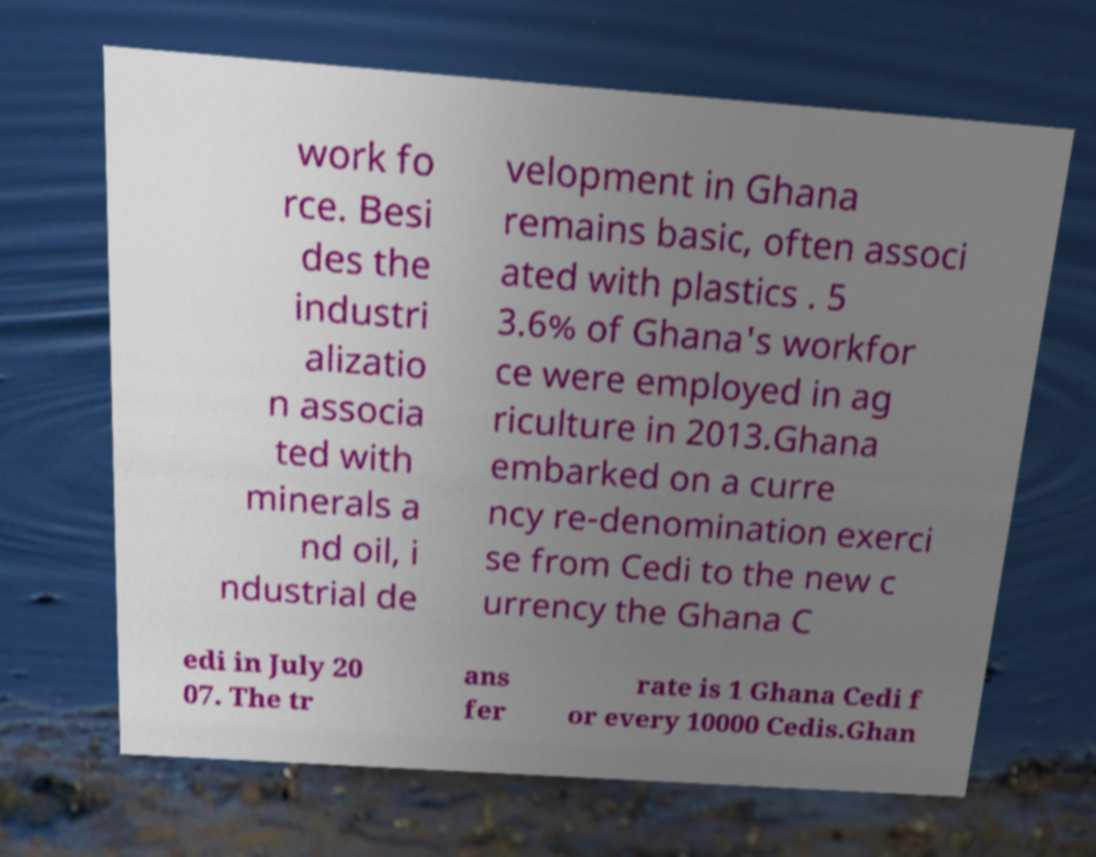For documentation purposes, I need the text within this image transcribed. Could you provide that? work fo rce. Besi des the industri alizatio n associa ted with minerals a nd oil, i ndustrial de velopment in Ghana remains basic, often associ ated with plastics . 5 3.6% of Ghana's workfor ce were employed in ag riculture in 2013.Ghana embarked on a curre ncy re-denomination exerci se from Cedi to the new c urrency the Ghana C edi in July 20 07. The tr ans fer rate is 1 Ghana Cedi f or every 10000 Cedis.Ghan 